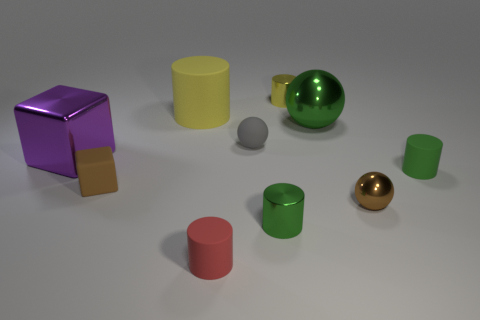Is the number of rubber objects behind the red matte cylinder greater than the number of large yellow cylinders that are behind the yellow rubber cylinder?
Offer a very short reply. Yes. What size is the green metal object that is the same shape as the small gray matte thing?
Offer a terse response. Large. What number of cubes are either large objects or small brown matte objects?
Your answer should be compact. 2. There is a small block that is the same color as the tiny metal sphere; what is it made of?
Your response must be concise. Rubber. Are there fewer brown balls that are on the left side of the rubber ball than small brown objects on the left side of the yellow metal thing?
Your response must be concise. Yes. How many objects are large things right of the small brown rubber thing or red matte cylinders?
Make the answer very short. 3. There is a tiny brown object that is to the right of the yellow thing that is left of the red cylinder; what is its shape?
Your answer should be very brief. Sphere. Are there any cyan rubber cylinders that have the same size as the green shiny cylinder?
Provide a succinct answer. No. Are there more large purple blocks than small green cylinders?
Provide a succinct answer. No. There is a yellow object that is left of the matte sphere; is its size the same as the metal cylinder that is behind the brown metal object?
Your answer should be compact. No. 